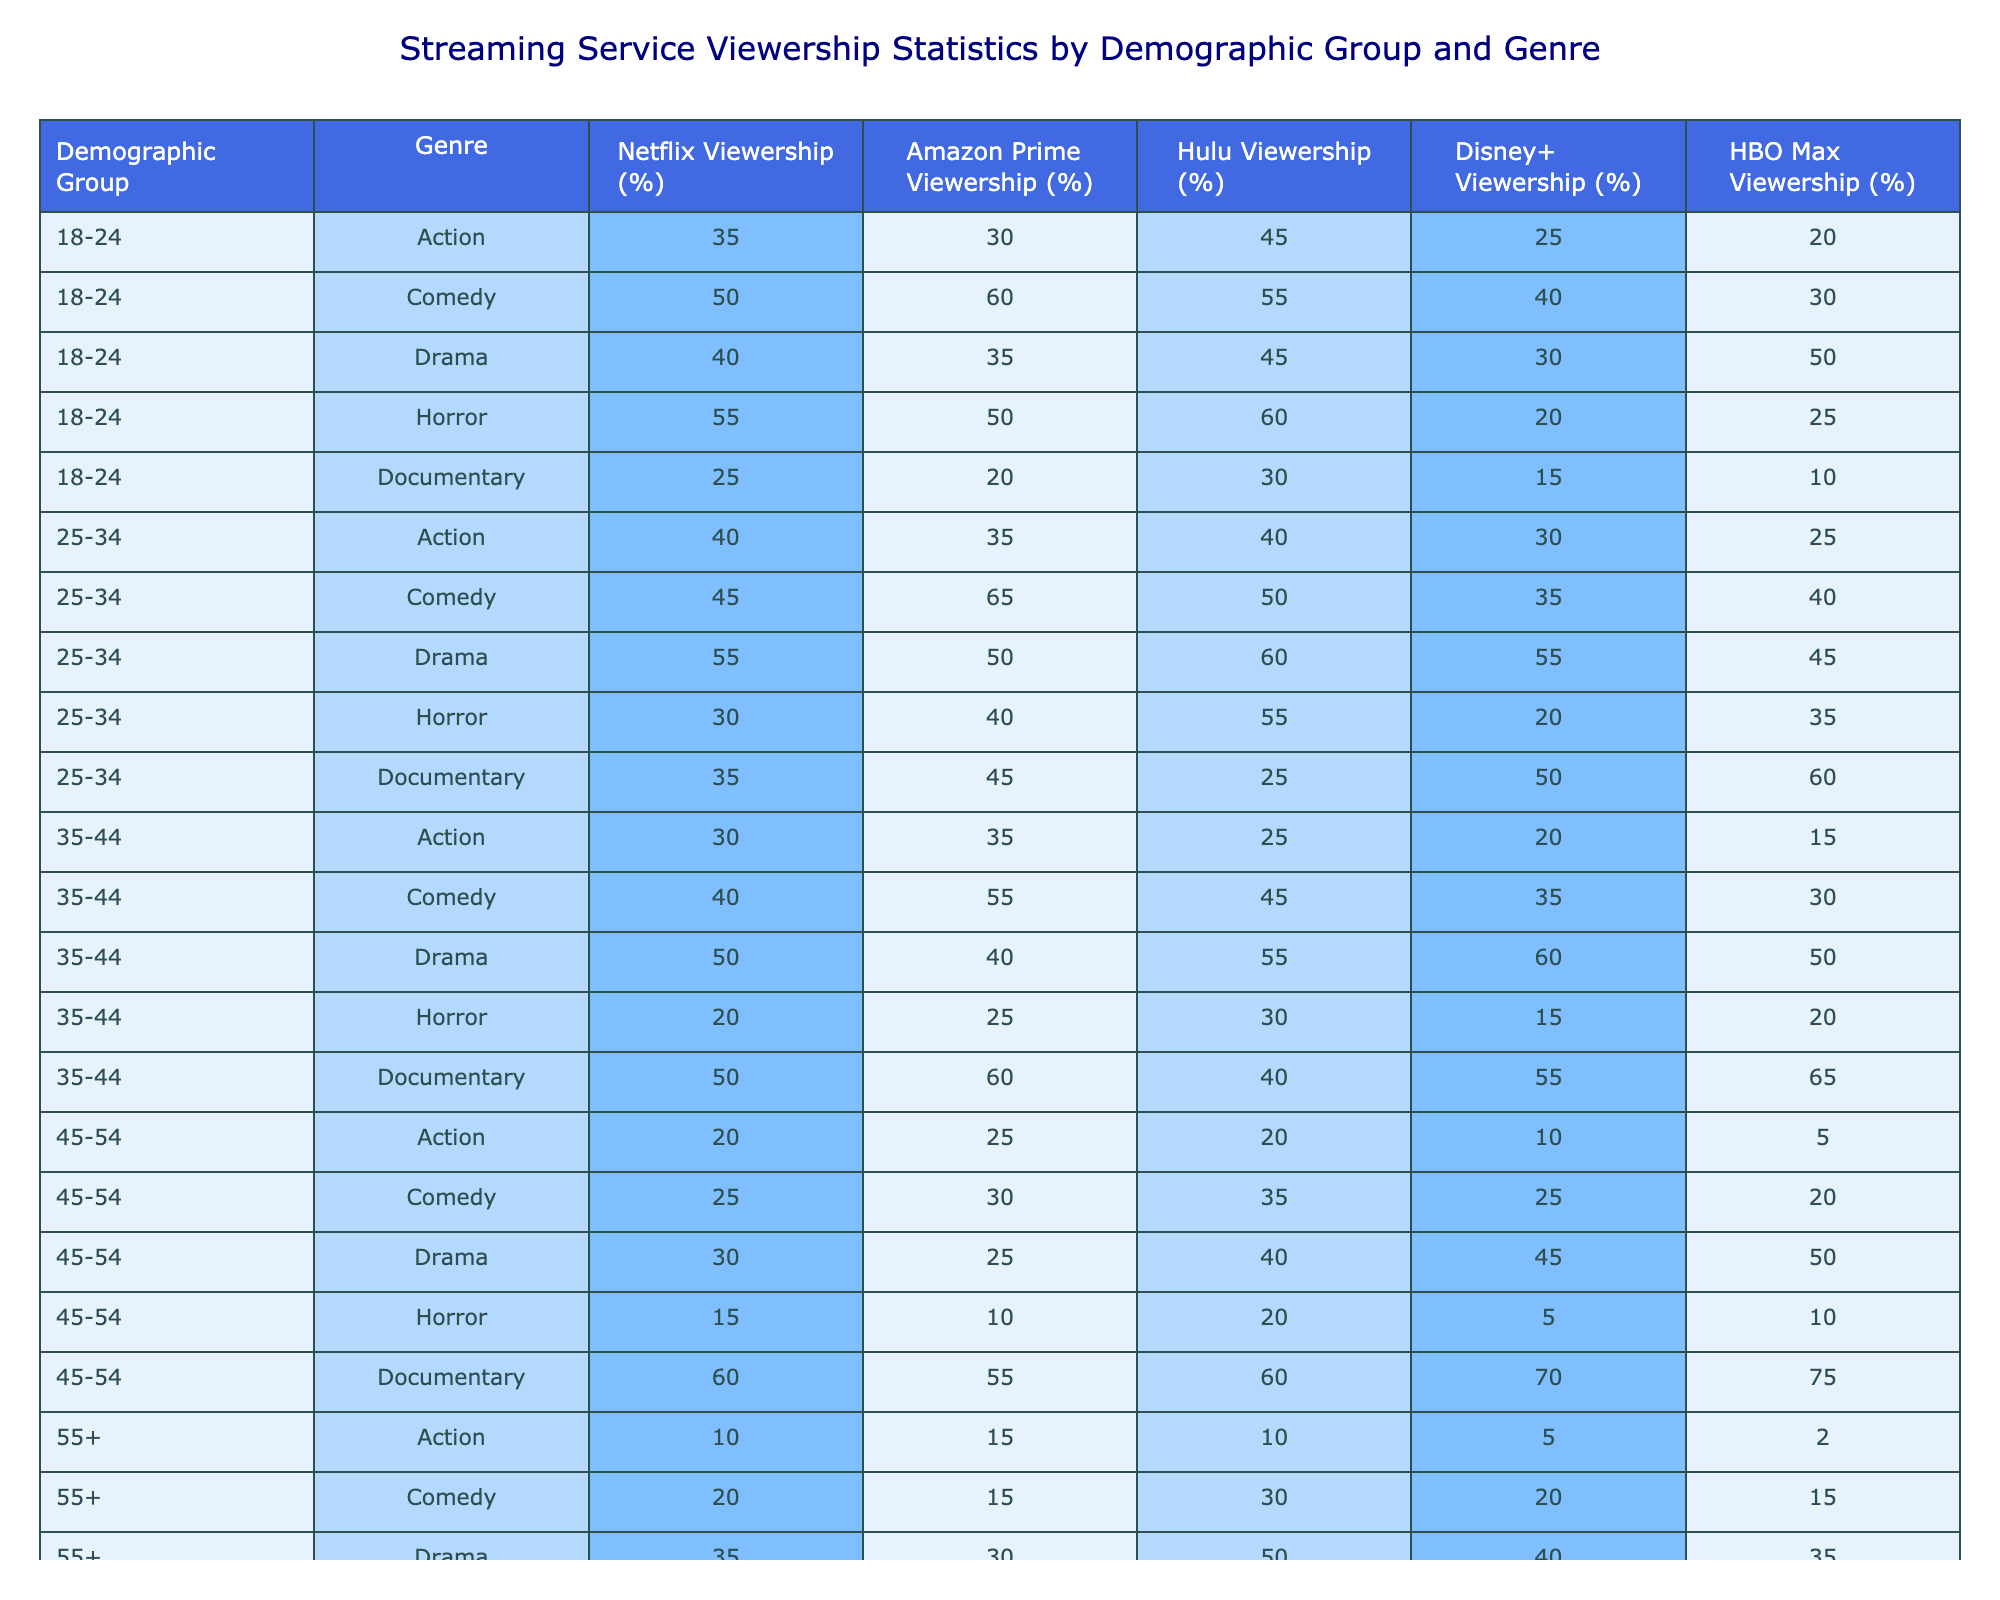What is the highest percentage of viewership for the Comedy genre among all demographic groups? In the Comedy genre, the highest percentage of viewership is 65%, which comes from the 25-34 demographic group on Amazon Prime.
Answer: 65% Which demographic group has the lowest viewership percentage for the Action genre on Netflix? For the Action genre on Netflix, the lowest viewership percentage is 10%, which comes from the 55+ demographic group.
Answer: 10% What is the total viewership percentage for the Drama genre across all streaming services for the 35-44 age group? The viewership percentages for the Drama genre in the 35-44 age group are: Netflix 50%, Amazon Prime 40%, Hulu 55%, Disney+ 60%, HBO Max 50%. Summing these yields: 50 + 40 + 55 + 60 + 50 = 255%.
Answer: 255% Is the viewership percentage for Documentaries higher in the 45-54 age group than in the 18-24 age group across all streaming services? For Documentaries, the total viewership percentage for the 45-54 age group is: Netflix 60%, Amazon Prime 55%, Hulu 60%, Disney+ 70%, HBO Max 75% = 320%. For the 18-24 age group, it is: Netflix 25%, Amazon Prime 20%, Hulu 30%, Disney+ 15%, HBO Max 10% = 100%. Since 320% is greater than 100%, the 45-54 age group has higher viewership.
Answer: Yes What is the average viewership for the Horror genre across all streaming services for the 25-34 age group? The percentages for Horror in the 25-34 age group are: Netflix 30%, Amazon Prime 40%, Hulu 55%, Disney+ 20%, HBO Max 35%. Adding these gives: 30 + 40 + 55 + 20 + 35 = 180%. To find the average, divide 180 by the number of services (5), yielding: 180/5 = 36%.
Answer: 36% Which streaming service has the highest viewership for Documentaries among individuals aged 55 and over? For the 55+ age group, the viewership percentages for Documentaries are: Netflix 70%, Amazon Prime 75%, Hulu 65%, Disney+ 80%, HBO Max 85%. The highest percentage is 85% from HBO Max.
Answer: HBO Max Are more people aged 18-24 choosing Horror on Hulu than Action on Netflix? For 18-24 year-olds, Hulu's viewership percentage for Horror is 60%, while Netflix's viewership percentage for Action is 35%. Since 60% is greater than 35%, more people are choosing Horror on Hulu than Action on Netflix.
Answer: Yes What is the difference in percentage of viewership between Comedy and Drama for the 25-34 demographic on Netflix? The viewership for Comedy in the 25-34 demographic on Netflix is 45%, while for Drama it is 55%. The difference is calculated as 55% - 45% = 10%.
Answer: 10% Which age group shows the least interest in the Action genre on Disney+? The viewership percentages for Action on Disney+ across age groups are: 18-24 (25%), 25-34 (30%), 35-44 (20%), 45-54 (10%), and 55+ (5%). Among these, 5% from the 55+ age group is the lowest.
Answer: 55+ What is the total viewership percentage for all genres on Amazon Prime for the 35-44 age group? The viewership percentages for all genres on Amazon Prime in the 35-44 age group are: Action 35%, Comedy 55%, Drama 40%, Horror 25%, Documentary 60%. Summing these: 35 + 55 + 40 + 25 + 60 = 215%.
Answer: 215% For the Comedy genre, how does the viewership for individuals aged 45-54 compare with that of those aged 25-34 on HBO Max? For Comedy, the viewership for the 45-54 age group on HBO Max is 20%, and for the 25-34 age group, it is 40%. The comparison shows that 40% (25-34) is higher than 20% (45-54).
Answer: 40% is higher 